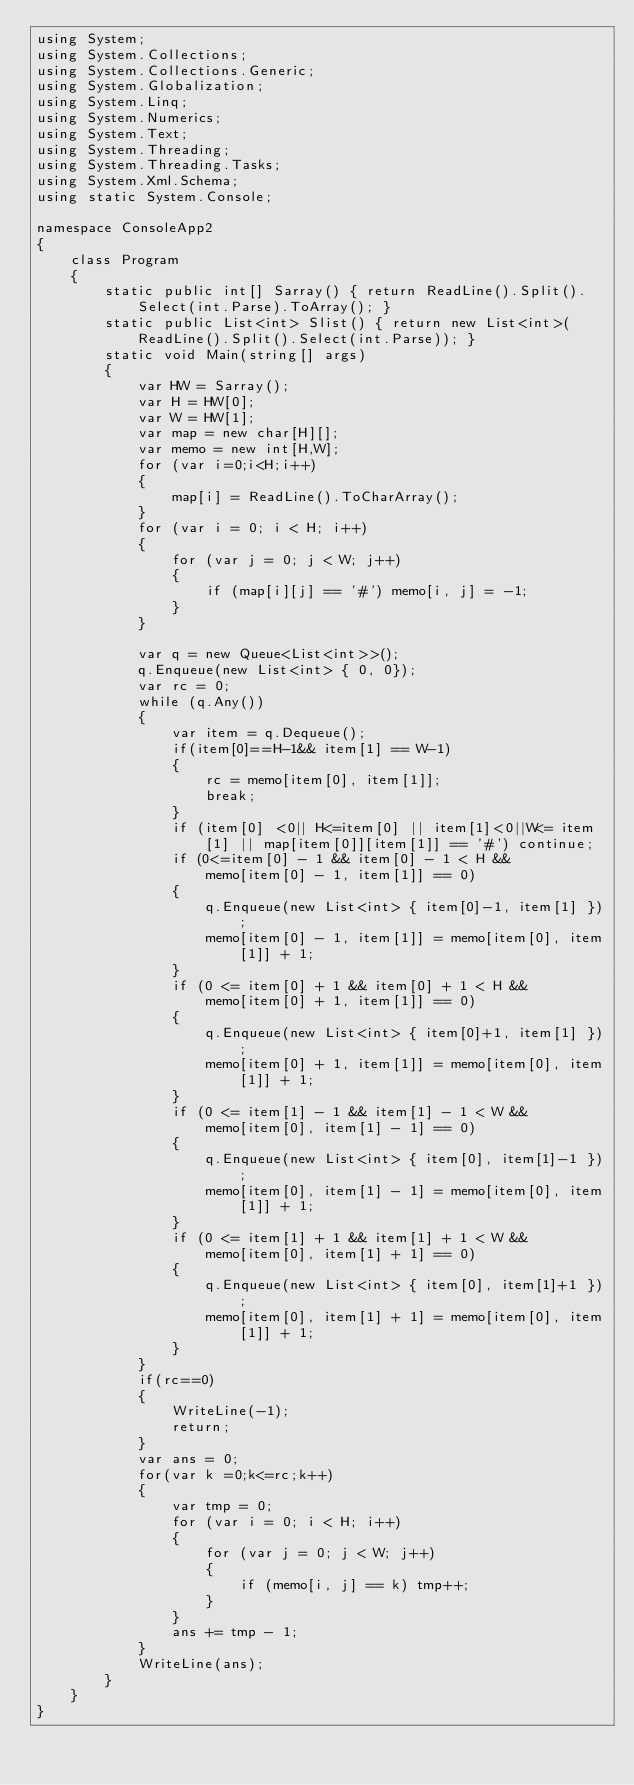Convert code to text. <code><loc_0><loc_0><loc_500><loc_500><_C#_>using System;
using System.Collections;
using System.Collections.Generic;
using System.Globalization;
using System.Linq;
using System.Numerics;
using System.Text;
using System.Threading;
using System.Threading.Tasks;
using System.Xml.Schema;
using static System.Console;

namespace ConsoleApp2
{
    class Program
    {
        static public int[] Sarray() { return ReadLine().Split().Select(int.Parse).ToArray(); }
        static public List<int> Slist() { return new List<int>(ReadLine().Split().Select(int.Parse)); }
        static void Main(string[] args)
        {
            var HW = Sarray();
            var H = HW[0];
            var W = HW[1];
            var map = new char[H][];
            var memo = new int[H,W];
            for (var i=0;i<H;i++)
            {
                map[i] = ReadLine().ToCharArray();
            }
            for (var i = 0; i < H; i++)
            {
                for (var j = 0; j < W; j++)
                {
                    if (map[i][j] == '#') memo[i, j] = -1;
                }
            }

            var q = new Queue<List<int>>();
            q.Enqueue(new List<int> { 0, 0});
            var rc = 0;
            while (q.Any())
            {
                var item = q.Dequeue();
                if(item[0]==H-1&& item[1] == W-1)
                {
                    rc = memo[item[0], item[1]];
                    break;
                }
                if (item[0] <0|| H<=item[0] || item[1]<0||W<= item[1] || map[item[0]][item[1]] == '#') continue;
                if (0<=item[0] - 1 && item[0] - 1 < H &&
                    memo[item[0] - 1, item[1]] == 0)
                {
                    q.Enqueue(new List<int> { item[0]-1, item[1] });
                    memo[item[0] - 1, item[1]] = memo[item[0], item[1]] + 1;
                }
                if (0 <= item[0] + 1 && item[0] + 1 < H &&
                    memo[item[0] + 1, item[1]] == 0)
                {
                    q.Enqueue(new List<int> { item[0]+1, item[1] });
                    memo[item[0] + 1, item[1]] = memo[item[0], item[1]] + 1;
                }
                if (0 <= item[1] - 1 && item[1] - 1 < W &&
                    memo[item[0], item[1] - 1] == 0)
                {
                    q.Enqueue(new List<int> { item[0], item[1]-1 });
                    memo[item[0], item[1] - 1] = memo[item[0], item[1]] + 1;
                }
                if (0 <= item[1] + 1 && item[1] + 1 < W &&
                    memo[item[0], item[1] + 1] == 0)
                {
                    q.Enqueue(new List<int> { item[0], item[1]+1 });
                    memo[item[0], item[1] + 1] = memo[item[0], item[1]] + 1;
                }
            }
            if(rc==0)
            {
                WriteLine(-1);
                return;
            }
            var ans = 0;
            for(var k =0;k<=rc;k++)
            {
                var tmp = 0;
                for (var i = 0; i < H; i++)
                {
                    for (var j = 0; j < W; j++)
                    {
                        if (memo[i, j] == k) tmp++;
                    }
                }
                ans += tmp - 1;
            }
            WriteLine(ans);
        }
    }
}</code> 